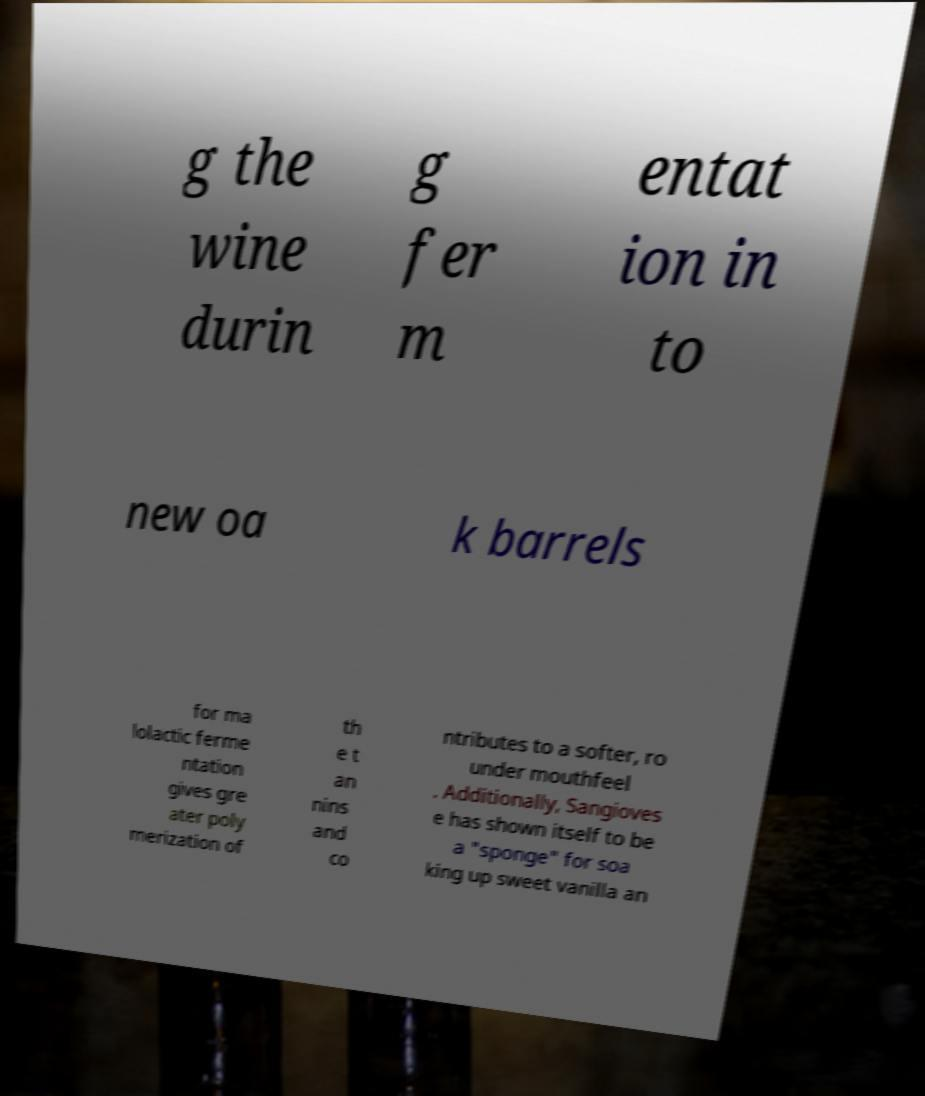For documentation purposes, I need the text within this image transcribed. Could you provide that? g the wine durin g fer m entat ion in to new oa k barrels for ma lolactic ferme ntation gives gre ater poly merization of th e t an nins and co ntributes to a softer, ro under mouthfeel . Additionally, Sangioves e has shown itself to be a "sponge" for soa king up sweet vanilla an 